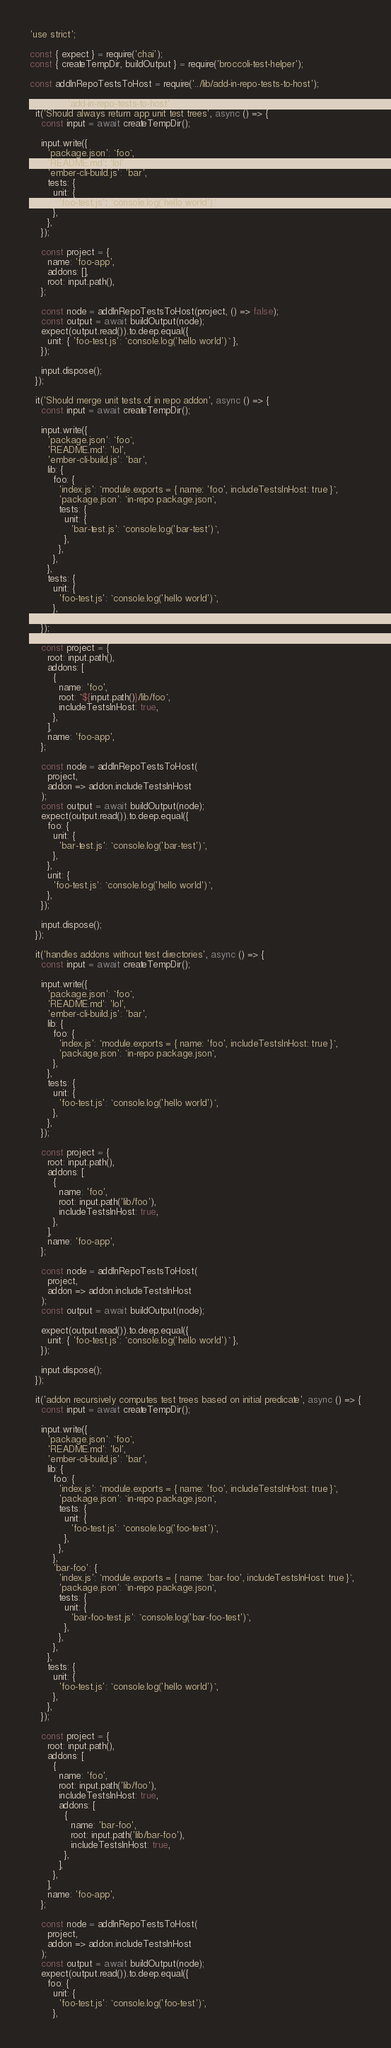Convert code to text. <code><loc_0><loc_0><loc_500><loc_500><_JavaScript_>'use strict';

const { expect } = require('chai');
const { createTempDir, buildOutput } = require('broccoli-test-helper');

const addInRepoTestsToHost = require('../lib/add-in-repo-tests-to-host');

describe('add-in-repo-tests-to-host', () => {
  it('Should always return app unit test trees', async () => {
    const input = await createTempDir();

    input.write({
      'package.json': `foo`,
      'README.md': 'lol',
      'ember-cli-build.js': 'bar',
      tests: {
        unit: {
          'foo-test.js': `console.log('hello world')`,
        },
      },
    });

    const project = {
      name: 'foo-app',
      addons: [],
      root: input.path(),
    };

    const node = addInRepoTestsToHost(project, () => false);
    const output = await buildOutput(node);
    expect(output.read()).to.deep.equal({
      unit: { 'foo-test.js': `console.log('hello world')` },
    });

    input.dispose();
  });

  it('Should merge unit tests of in repo addon', async () => {
    const input = await createTempDir();

    input.write({
      'package.json': `foo`,
      'README.md': 'lol',
      'ember-cli-build.js': 'bar',
      lib: {
        foo: {
          'index.js': `module.exports = { name: 'foo', includeTestsInHost: true }`,
          'package.json': `in-repo package.json`,
          tests: {
            unit: {
              'bar-test.js': `console.log('bar-test')`,
            },
          },
        },
      },
      tests: {
        unit: {
          'foo-test.js': `console.log('hello world')`,
        },
      },
    });

    const project = {
      root: input.path(),
      addons: [
        {
          name: 'foo',
          root: `${input.path()}/lib/foo`,
          includeTestsInHost: true,
        },
      ],
      name: 'foo-app',
    };

    const node = addInRepoTestsToHost(
      project,
      addon => addon.includeTestsInHost
    );
    const output = await buildOutput(node);
    expect(output.read()).to.deep.equal({
      foo: {
        unit: {
          'bar-test.js': `console.log('bar-test')`,
        },
      },
      unit: {
        'foo-test.js': `console.log('hello world')`,
      },
    });

    input.dispose();
  });

  it('handles addons without test directories', async () => {
    const input = await createTempDir();

    input.write({
      'package.json': `foo`,
      'README.md': 'lol',
      'ember-cli-build.js': 'bar',
      lib: {
        foo: {
          'index.js': `module.exports = { name: 'foo', includeTestsInHost: true }`,
          'package.json': `in-repo package.json`,
        },
      },
      tests: {
        unit: {
          'foo-test.js': `console.log('hello world')`,
        },
      },
    });

    const project = {
      root: input.path(),
      addons: [
        {
          name: 'foo',
          root: input.path('lib/foo'),
          includeTestsInHost: true,
        },
      ],
      name: 'foo-app',
    };

    const node = addInRepoTestsToHost(
      project,
      addon => addon.includeTestsInHost
    );
    const output = await buildOutput(node);

    expect(output.read()).to.deep.equal({
      unit: { 'foo-test.js': `console.log('hello world')` },
    });

    input.dispose();
  });

  it('addon recursively computes test trees based on initial predicate', async () => {
    const input = await createTempDir();

    input.write({
      'package.json': `foo`,
      'README.md': 'lol',
      'ember-cli-build.js': 'bar',
      lib: {
        foo: {
          'index.js': `module.exports = { name: 'foo', includeTestsInHost: true }`,
          'package.json': `in-repo package.json`,
          tests: {
            unit: {
              'foo-test.js': `console.log('foo-test')`,
            },
          },
        },
        'bar-foo': {
          'index.js': `module.exports = { name: 'bar-foo', includeTestsInHost: true }`,
          'package.json': `in-repo package.json`,
          tests: {
            unit: {
              'bar-foo-test.js': `console.log('bar-foo-test')`,
            },
          },
        },
      },
      tests: {
        unit: {
          'foo-test.js': `console.log('hello world')`,
        },
      },
    });

    const project = {
      root: input.path(),
      addons: [
        {
          name: 'foo',
          root: input.path('lib/foo'),
          includeTestsInHost: true,
          addons: [
            {
              name: 'bar-foo',
              root: input.path('lib/bar-foo'),
              includeTestsInHost: true,
            },
          ],
        },
      ],
      name: 'foo-app',
    };

    const node = addInRepoTestsToHost(
      project,
      addon => addon.includeTestsInHost
    );
    const output = await buildOutput(node);
    expect(output.read()).to.deep.equal({
      foo: {
        unit: {
          'foo-test.js': `console.log('foo-test')`,
        },</code> 